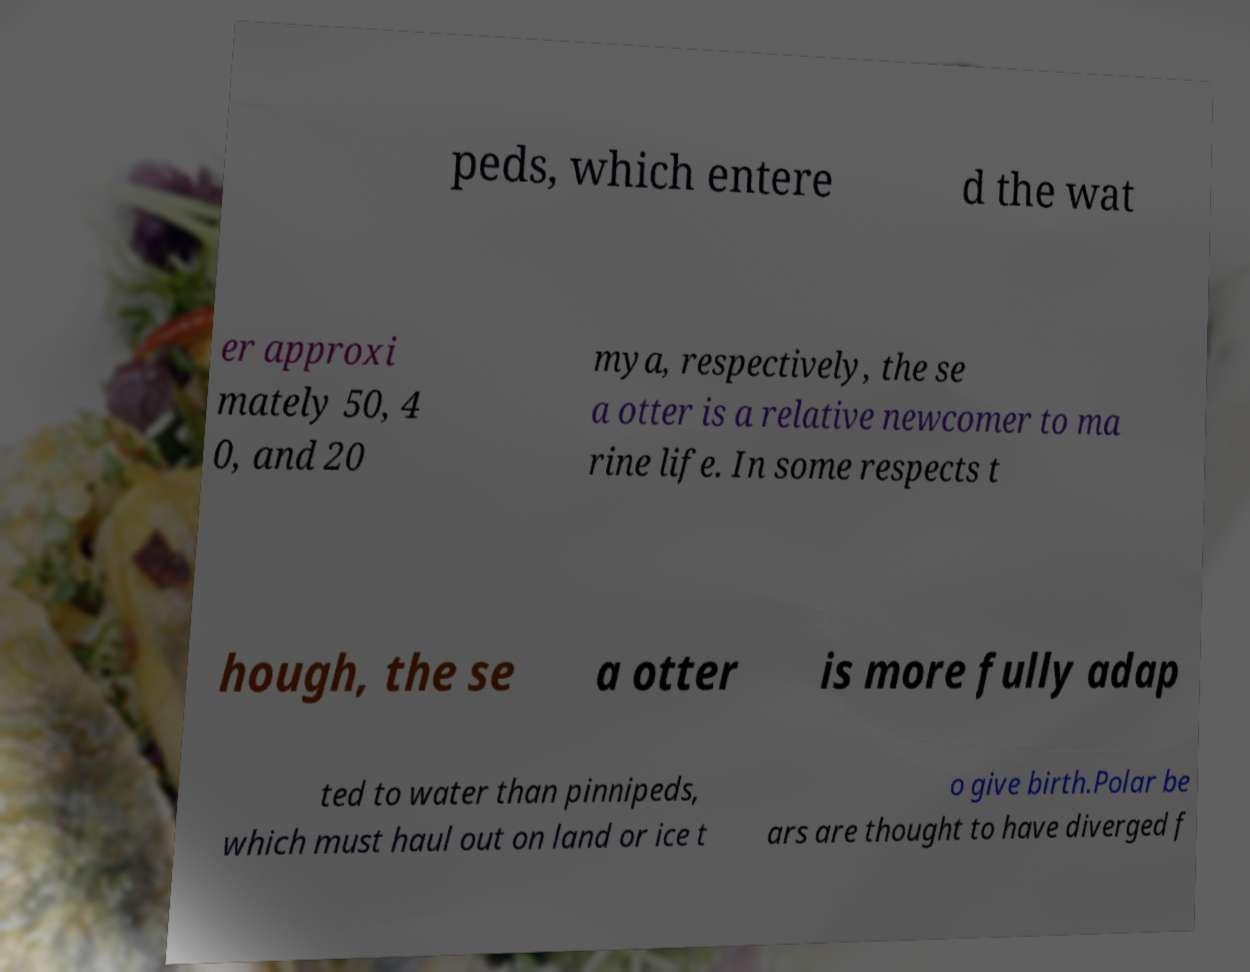Can you accurately transcribe the text from the provided image for me? peds, which entere d the wat er approxi mately 50, 4 0, and 20 mya, respectively, the se a otter is a relative newcomer to ma rine life. In some respects t hough, the se a otter is more fully adap ted to water than pinnipeds, which must haul out on land or ice t o give birth.Polar be ars are thought to have diverged f 